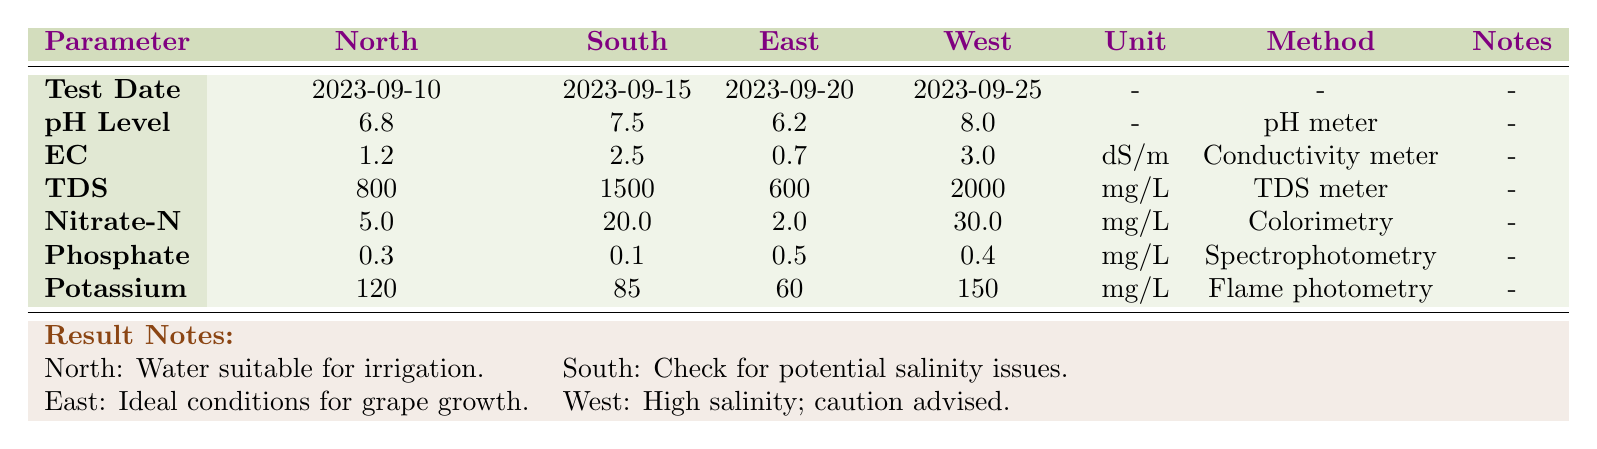What is the pH level of water in the South Vineyard Block? The table shows a direct measurement for the South Vineyard Block, where the pH level is listed clearly. The value is 7.5.
Answer: 7.5 What are the Total Dissolved Solids (TDS) values for all vineyard blocks combined? To find the TDS values, we sum the individual readings: 800 mg/L (North) + 1500 mg/L (South) + 600 mg/L (East) + 2000 mg/L (West) = 3900 mg/L.
Answer: 3900 mg/L Is the water in the East Vineyard Block suitable for irrigation? According to the result notes for the East Vineyard Block, it states "Ideal conditions for grape growth," indicating it is suitable for irrigation.
Answer: Yes What is the difference in Nitrate Nitrogen levels between the South and East Vineyard Blocks? The Nitrate Nitrogen level in South is 20.0 mg/L and in East is 2.0 mg/L. The difference is 20.0 - 2.0 = 18.0 mg/L.
Answer: 18.0 mg/L Which vineyard block has the highest Electrical Conductivity (EC)? By comparing the EC values listed, North has 1.2 dS/m, South has 2.5 dS/m, East has 0.7 dS/m, and West has 3.0 dS/m. West has the highest value of 3.0 dS/m.
Answer: West What is the average Potassium level across all vineyard blocks? The Potassium levels are: 120 mg/L (North), 85 mg/L (South), 60 mg/L (East), and 150 mg/L (West). Summing them gives 120 + 85 + 60 + 150 = 415 mg/L. There are 4 values, so the average is 415 mg/L / 4 = 103.75 mg/L.
Answer: 103.75 mg/L Is the phosphate level in the North Vineyard Block higher than that in the South Vineyard Block? The phosphate in North is 0.3 mg/L and in South is 0.1 mg/L. Since 0.3 > 0.1, this statement is true.
Answer: Yes Which Vineyard Block has the highest pH level? Looking at the pH levels: North is 6.8, South is 7.5, East is 6.2, and West is 8.0. By comparing these values, West has the highest pH level at 8.0.
Answer: West 